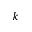Convert formula to latex. <formula><loc_0><loc_0><loc_500><loc_500>k</formula> 